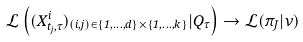<formula> <loc_0><loc_0><loc_500><loc_500>\mathcal { L } \left ( ( X ^ { i } _ { t _ { j } , \tau } ) _ { ( i , j ) \in \{ 1 , \dots , d \} \times \{ 1 , \dots , k \} } | Q _ { \tau } \right ) \rightarrow \mathcal { L } ( \pi _ { J } | \nu )</formula> 